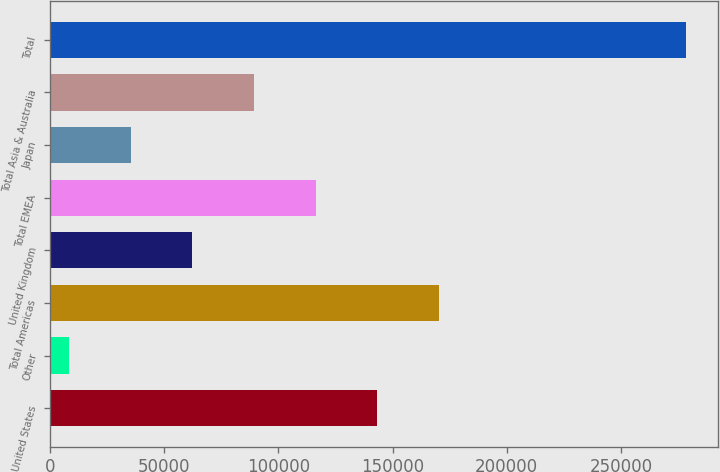Convert chart. <chart><loc_0><loc_0><loc_500><loc_500><bar_chart><fcel>United States<fcel>Other<fcel>Total Americas<fcel>United Kingdom<fcel>Total EMEA<fcel>Japan<fcel>Total Asia & Australia<fcel>Total<nl><fcel>143354<fcel>8235<fcel>170378<fcel>62282.8<fcel>116331<fcel>35258.9<fcel>89306.7<fcel>278474<nl></chart> 